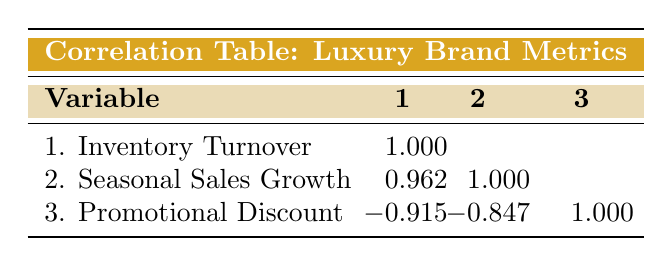What is the inventory turnover for Chanel? The table shows the specific metric for each brand. Looking at Chanel, the inventory turnover is listed under the relevant column.
Answer: 4.5 Which luxury brand has the highest seasonal sales growth? We compare the seasonal sales growth values across the brands. Louis Vuitton has the highest value of 12.0.
Answer: Louis Vuitton Is there a negative correlation between inventory turnover and promotional discount? The table indicates a value of -0.915 between these two metrics, confirming a negative correlation.
Answer: Yes What is the average inventory turnover for the luxury brands listed? We add the inventory turnovers of all the brands (4.5 + 3.8 + 5.0 + 2.9 + 4.2 + 3.5) = 24.9. There are 6 brands, so the average is 24.9/6 = 4.15.
Answer: 4.15 If we increase the promotional discount to 15%, what would likely happen to the inventory turnover? Given the strong negative correlation (-0.915) between the promotional discount and inventory turnover, an increase in the discount is likely to decrease the inventory turnover based on this relationship.
Answer: Decrease What is the seasonal sales growth for Versace? Referring to the seasonal sales growth column for Versace in the table, the value is easily identifiable.
Answer: 6.5 Which brand has both the highest inventory turnover and seasonal sales growth? Assessing the data, Louis Vuitton has the highest inventory turnover at 5.0 and also the highest seasonal sales growth at 12.0, making it the only brand excelling in both metrics.
Answer: Louis Vuitton Is it true that all Fall/Winter brands have an inventory turnover below 4? The brands for the Fall/Winter season (Gucci, Prada, and Versace) show inventory turnovers of 3.8, 2.9, and 3.5 respectively, all of which are below 4.
Answer: Yes What is the difference in inventory turnover between Louis Vuitton and Prada? We find the inventory turnovers for these brands: Louis Vuitton has 5.0 and Prada has 2.9. The difference is calculated as 5.0 - 2.9 = 2.1.
Answer: 2.1 